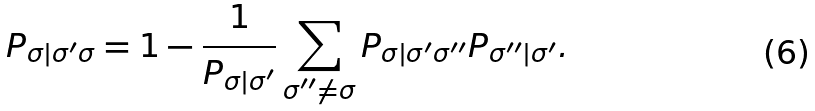Convert formula to latex. <formula><loc_0><loc_0><loc_500><loc_500>P _ { \sigma | \sigma ^ { \prime } \sigma } = 1 - \frac { 1 } { P _ { \sigma | \sigma ^ { \prime } } } \sum _ { \sigma ^ { \prime \prime } \ne \sigma } P _ { \sigma | \sigma ^ { \prime } \sigma ^ { \prime \prime } } P _ { \sigma ^ { \prime \prime } | \sigma ^ { \prime } } .</formula> 